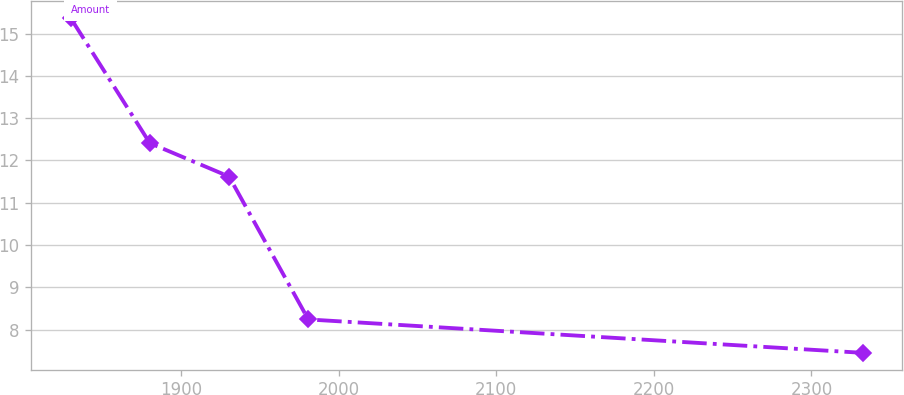Convert chart to OTSL. <chart><loc_0><loc_0><loc_500><loc_500><line_chart><ecel><fcel>Amount<nl><fcel>1830<fcel>15.37<nl><fcel>1880.26<fcel>12.41<nl><fcel>1930.52<fcel>11.62<nl><fcel>1980.78<fcel>8.24<nl><fcel>2332.61<fcel>7.45<nl></chart> 